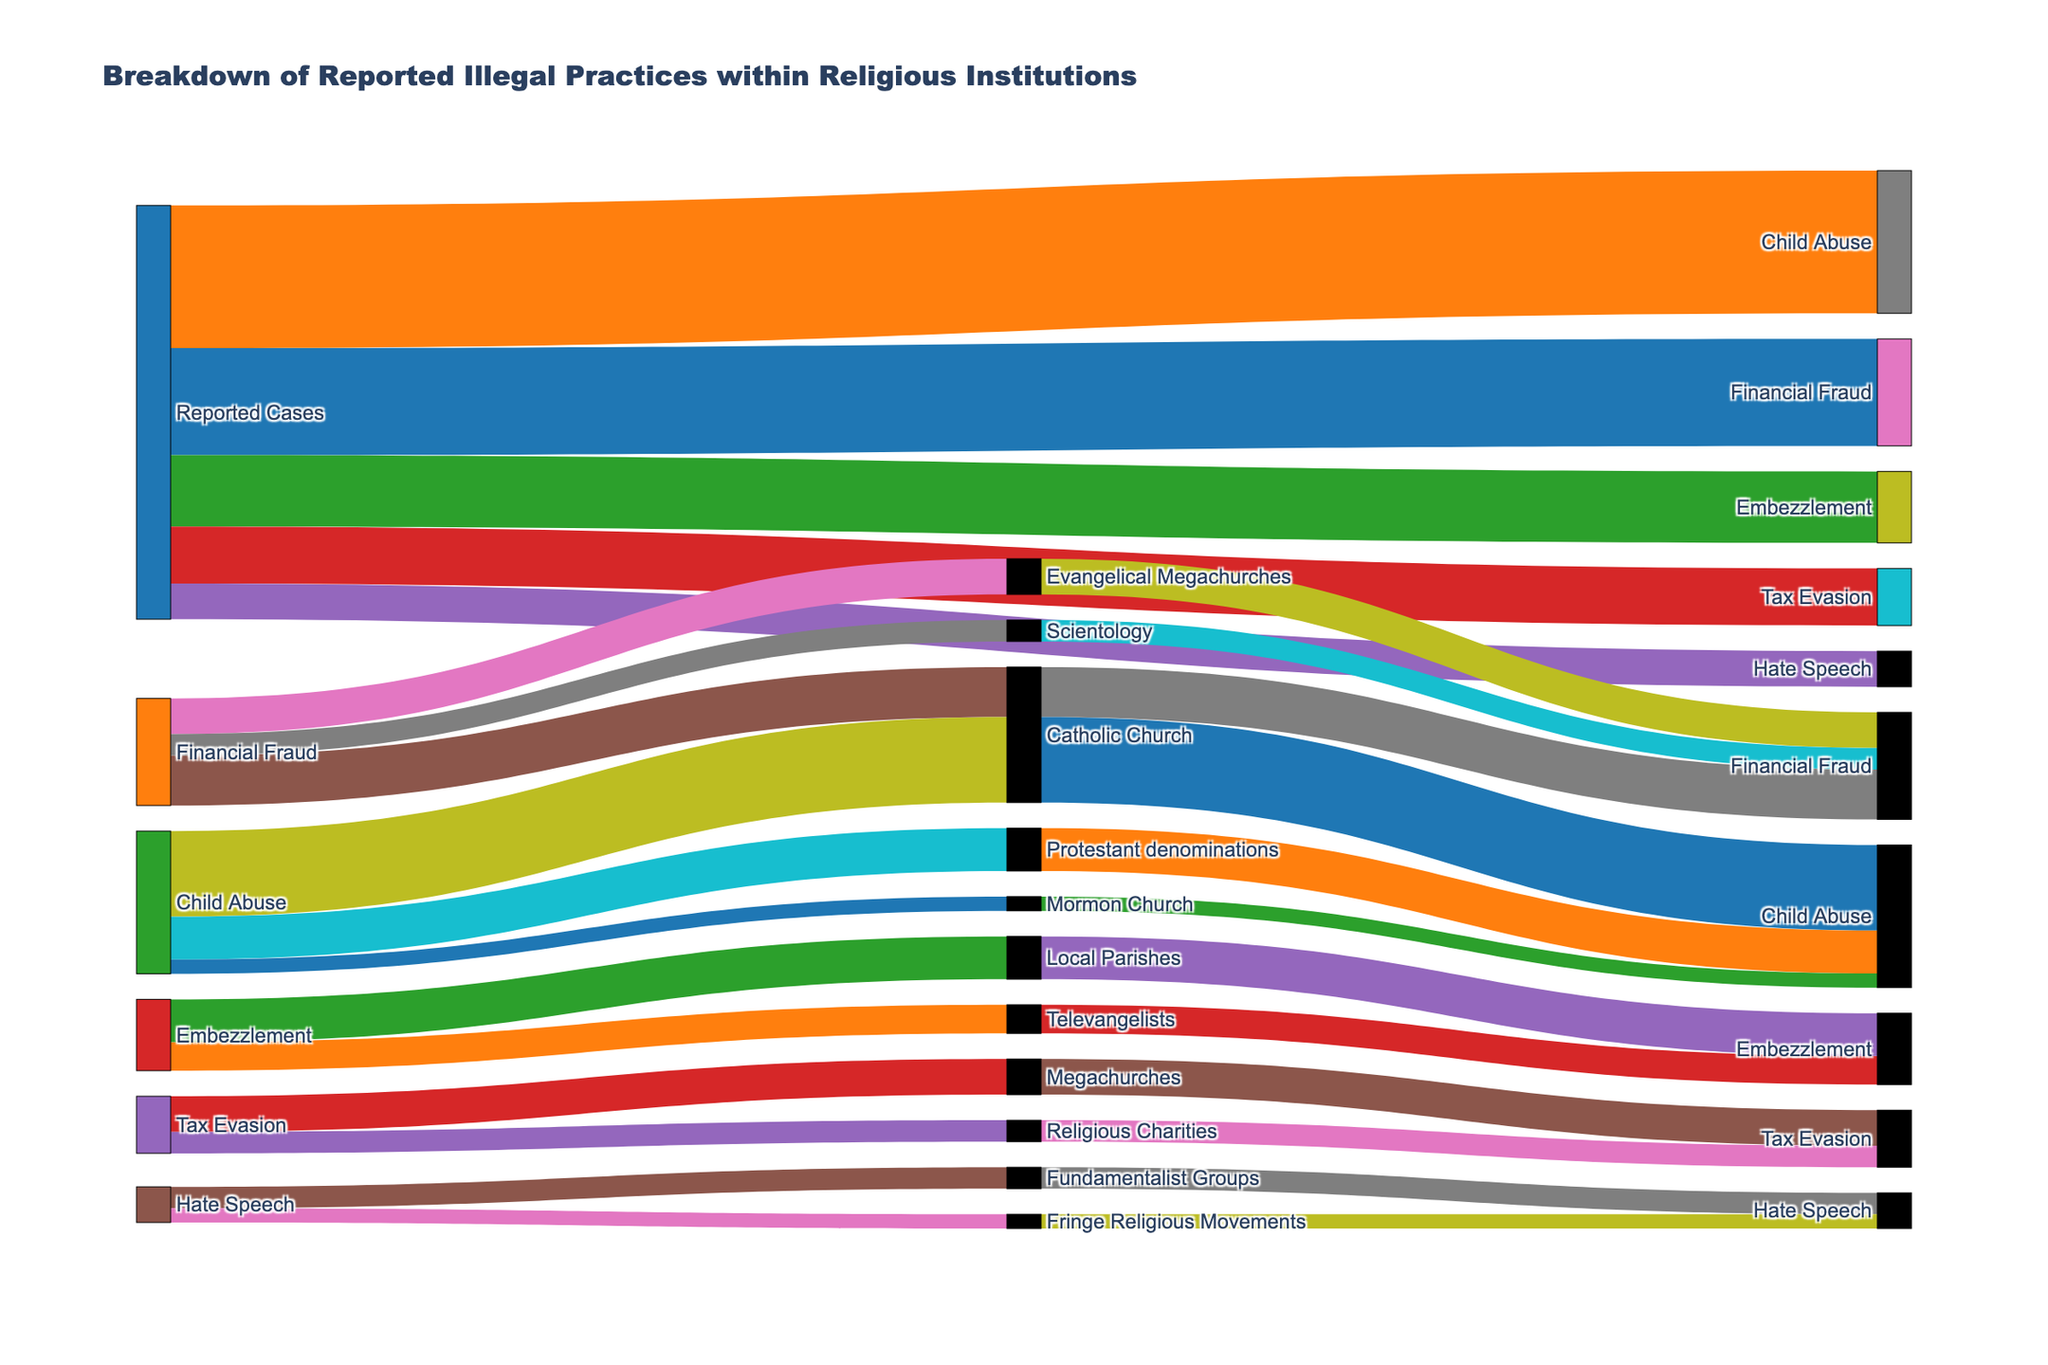What is the title of the figure? The title is typically displayed at the top of the figure and clearly indicates the subject or main topic of the visualization.
Answer: Breakdown of Reported Illegal Practices within Religious Institutions How many types of illegal practices are reported? Count the distinct categories connected from the 'Reported Cases'. Each name represents a type of illegal practices.
Answer: Five Which type of illegal practice has the highest frequency? Look for the type connected to 'Reported Cases' with the largest flow or value indicated in the connections.
Answer: Child Abuse What is the combined frequency of Financial Fraud and Embezzlement? Add the frequency values of Financial Fraud and Embezzlement, which are 150 and 100 respectively.
Answer: 250 Which religious institution is most frequently associated with Child Abuse? Identify the religious institutions connected to Child Abuse and find which has the largest flow or value.
Answer: Catholic Church Compare the frequency of Financial Fraud in Catholic Church and Evangelical Megachurches. Which has a higher frequency? Look at the values of the connections from Financial Fraud to Catholic Church and Evangelical Megachurches; compare 70 (Catholic Church) with 50 (Evangelical Megachurches).
Answer: Catholic Church What is the total frequency of Tax Evasion cases connected to Megachurches and Religious Charities? Sum the frequency values of Tax Evasion cases for Megachurches (50) and Religious Charities (30).
Answer: 80 How many total cases of hate speech are reported across all religious institutions listed? Add the frequencies of Hate Speech cases in Fundamentalist Groups (30) and Fringe Religious Movements (20).
Answer: 50 Which illegal practice has the least number of reported cases? Look for the type connected from 'Reported Cases' with the smallest value; in this case, it compares all practices and finds the smallest value.
Answer: Hate Speech In terms of frequency, how does Child Abuse compare to Tax Evasion? Compare the total frequency values of both types. Child Abuse has 200 and Tax Evasion has 80.
Answer: Child Abuse is much higher than Tax Evasion 